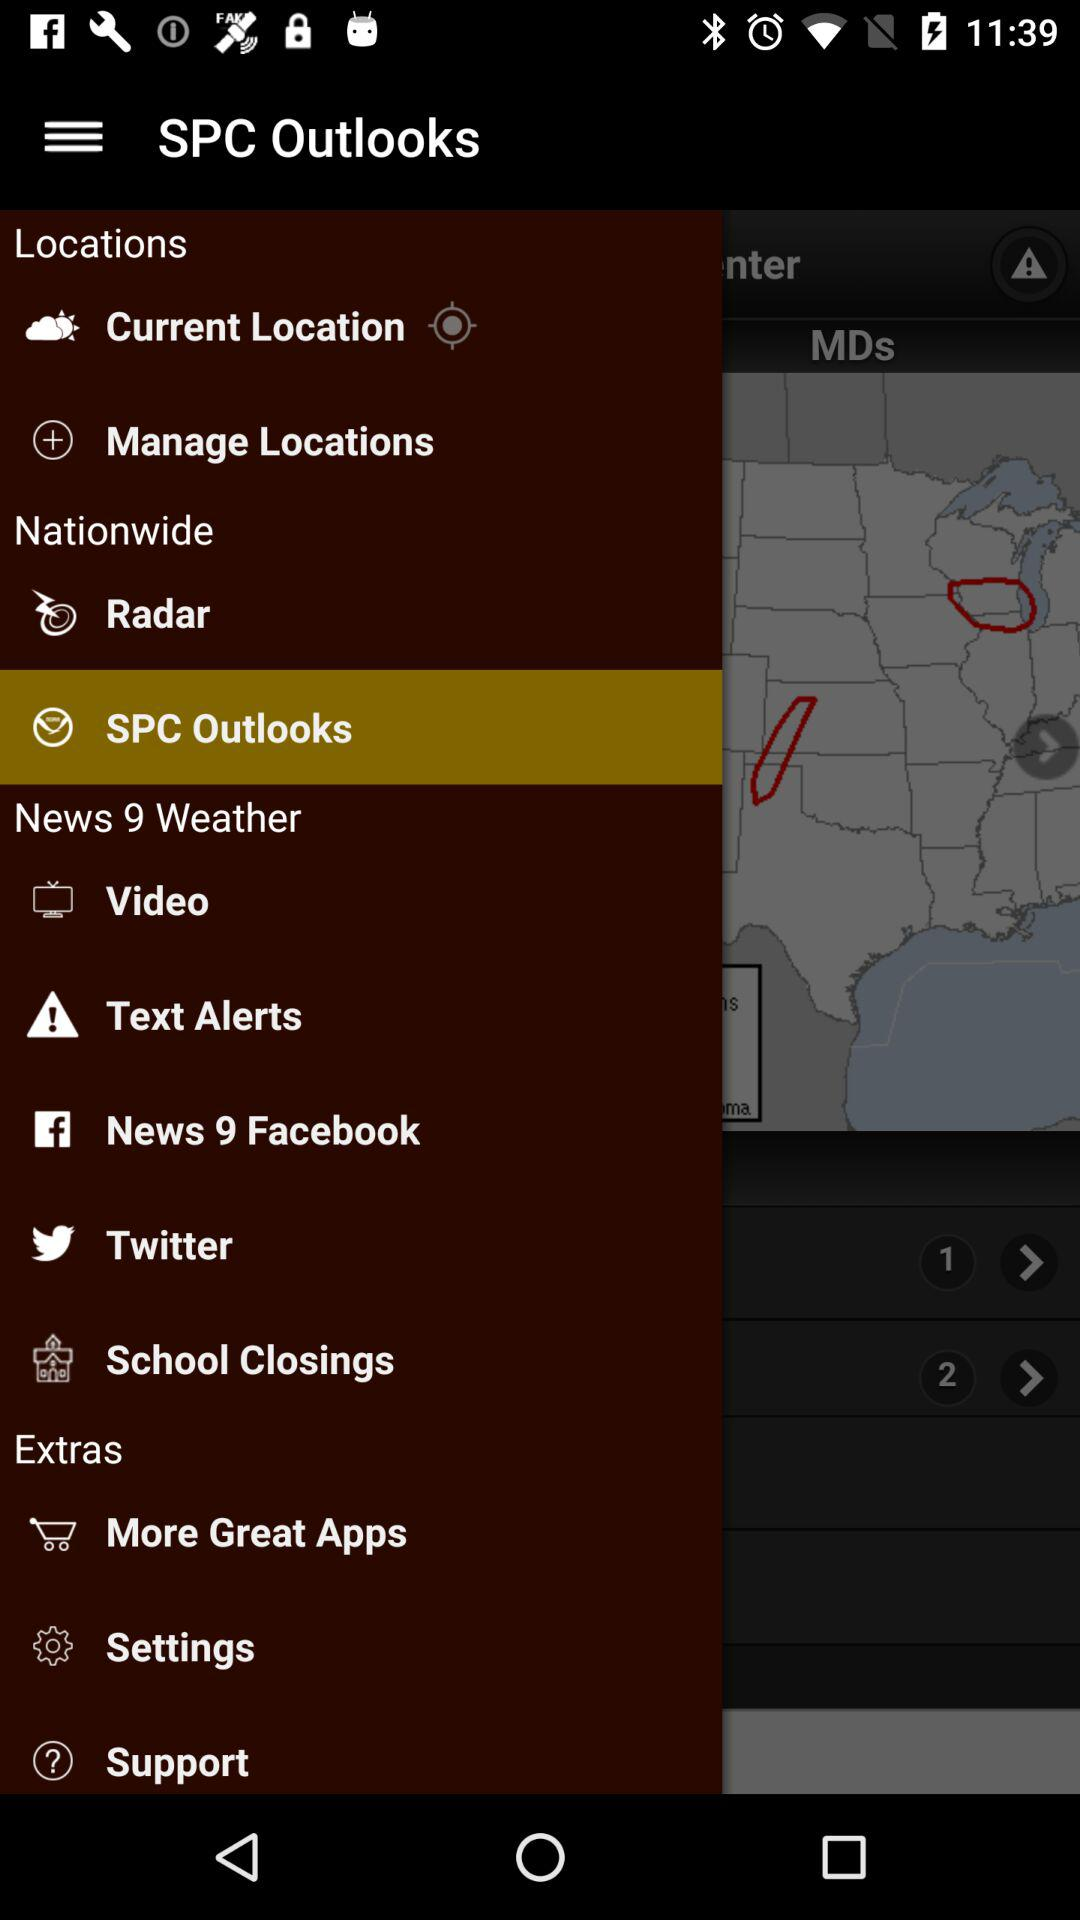What is the application name? The application name is "SPC Outlooks". 